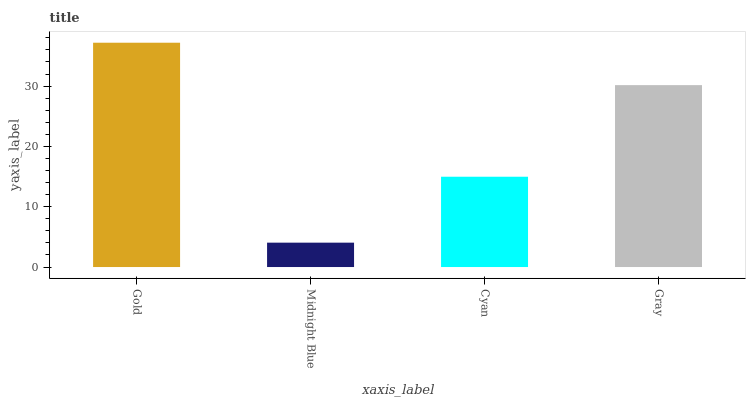Is Midnight Blue the minimum?
Answer yes or no. Yes. Is Gold the maximum?
Answer yes or no. Yes. Is Cyan the minimum?
Answer yes or no. No. Is Cyan the maximum?
Answer yes or no. No. Is Cyan greater than Midnight Blue?
Answer yes or no. Yes. Is Midnight Blue less than Cyan?
Answer yes or no. Yes. Is Midnight Blue greater than Cyan?
Answer yes or no. No. Is Cyan less than Midnight Blue?
Answer yes or no. No. Is Gray the high median?
Answer yes or no. Yes. Is Cyan the low median?
Answer yes or no. Yes. Is Gold the high median?
Answer yes or no. No. Is Gold the low median?
Answer yes or no. No. 